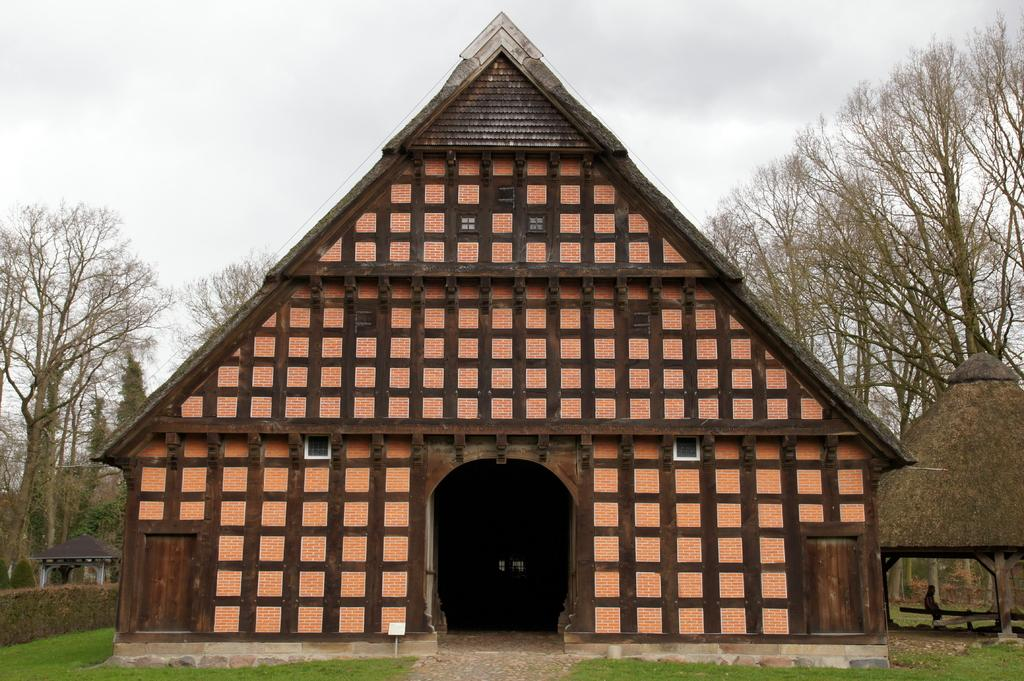What type of structure is in the image? There is a hut in the image. What color is the hut? The hut is brown in color. Is there anyone near the hut? Yes, there is a person to the right of the hut. What can be seen in the background of the image? There are many trees and the sky is visible in the background of the image. What type of skin condition does the person near the hut have? There is no information about the person's skin condition in the image. What is the person near the hut using to collect water? There is no bucket or any other water-collecting object visible in the image. 